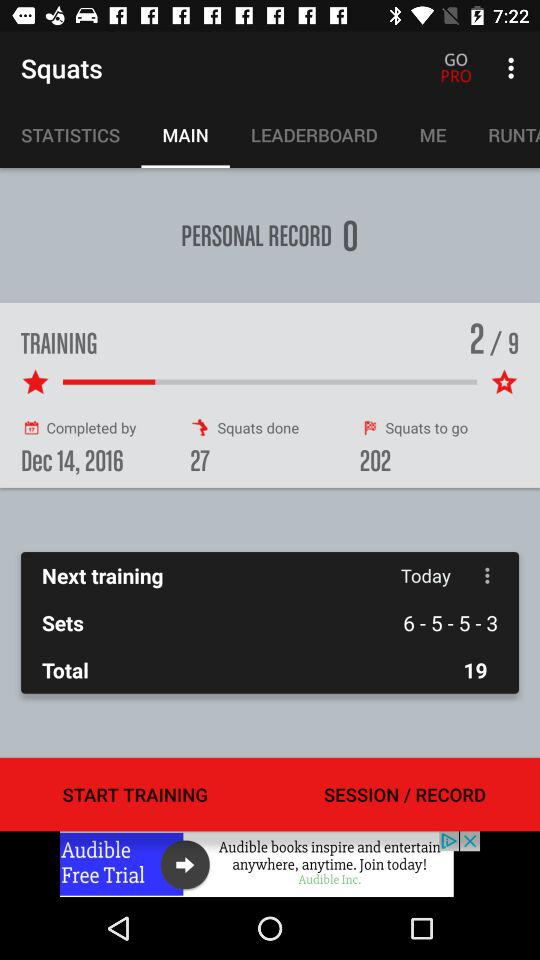What tab am I on? You are on the "MAIN" tab. 